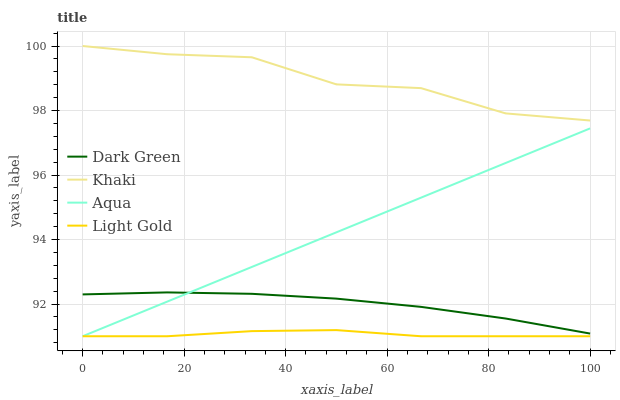Does Light Gold have the minimum area under the curve?
Answer yes or no. Yes. Does Khaki have the maximum area under the curve?
Answer yes or no. Yes. Does Aqua have the minimum area under the curve?
Answer yes or no. No. Does Aqua have the maximum area under the curve?
Answer yes or no. No. Is Aqua the smoothest?
Answer yes or no. Yes. Is Khaki the roughest?
Answer yes or no. Yes. Is Khaki the smoothest?
Answer yes or no. No. Is Aqua the roughest?
Answer yes or no. No. Does Light Gold have the lowest value?
Answer yes or no. Yes. Does Khaki have the lowest value?
Answer yes or no. No. Does Khaki have the highest value?
Answer yes or no. Yes. Does Aqua have the highest value?
Answer yes or no. No. Is Aqua less than Khaki?
Answer yes or no. Yes. Is Khaki greater than Aqua?
Answer yes or no. Yes. Does Light Gold intersect Aqua?
Answer yes or no. Yes. Is Light Gold less than Aqua?
Answer yes or no. No. Is Light Gold greater than Aqua?
Answer yes or no. No. Does Aqua intersect Khaki?
Answer yes or no. No. 